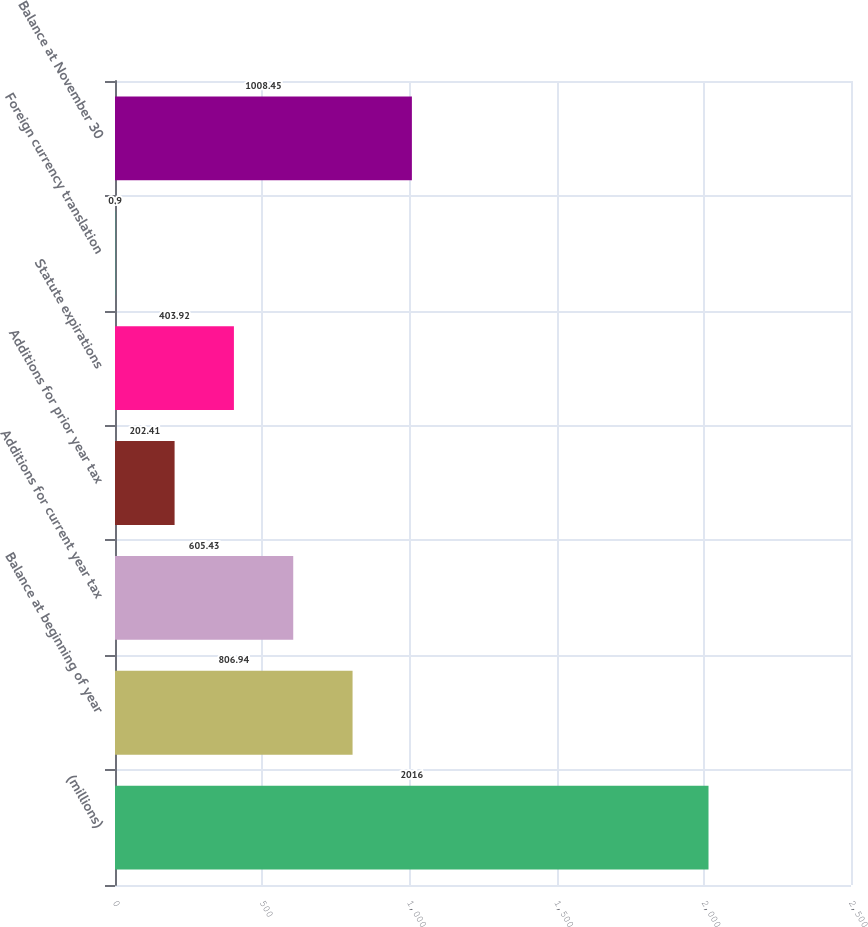Convert chart. <chart><loc_0><loc_0><loc_500><loc_500><bar_chart><fcel>(millions)<fcel>Balance at beginning of year<fcel>Additions for current year tax<fcel>Additions for prior year tax<fcel>Statute expirations<fcel>Foreign currency translation<fcel>Balance at November 30<nl><fcel>2016<fcel>806.94<fcel>605.43<fcel>202.41<fcel>403.92<fcel>0.9<fcel>1008.45<nl></chart> 